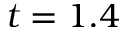<formula> <loc_0><loc_0><loc_500><loc_500>t = 1 . 4</formula> 